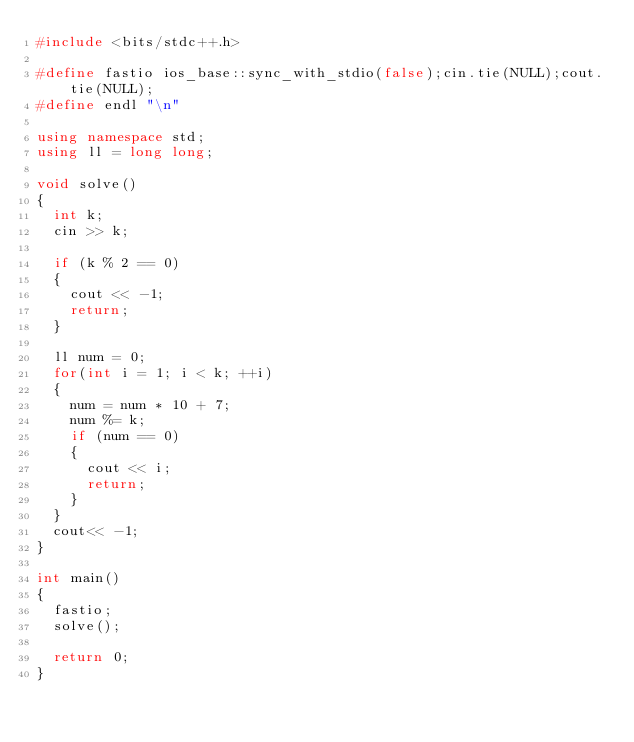<code> <loc_0><loc_0><loc_500><loc_500><_C++_>#include <bits/stdc++.h>

#define fastio ios_base::sync_with_stdio(false);cin.tie(NULL);cout.tie(NULL);
#define endl "\n"

using namespace std;
using ll = long long;

void solve()
{
  int k;
  cin >> k;

  if (k % 2 == 0)
  {
    cout << -1;
    return;
  }

  ll num = 0;
  for(int i = 1; i < k; ++i)
  {
    num = num * 10 + 7;
    num %= k;
    if (num == 0)
    {
      cout << i;
      return;
    }
  }  
  cout<< -1;
}

int main()
{
  fastio;
  solve();

  return 0;
}</code> 